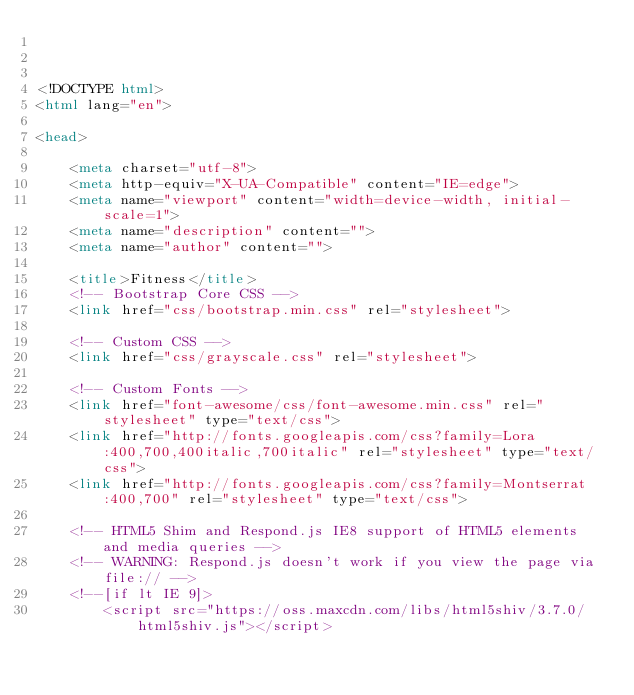<code> <loc_0><loc_0><loc_500><loc_500><_HTML_>


<!DOCTYPE html>
<html lang="en">

<head>

    <meta charset="utf-8">
    <meta http-equiv="X-UA-Compatible" content="IE=edge">
    <meta name="viewport" content="width=device-width, initial-scale=1">
    <meta name="description" content="">
    <meta name="author" content="">

    <title>Fitness</title>
    <!-- Bootstrap Core CSS -->
    <link href="css/bootstrap.min.css" rel="stylesheet">

    <!-- Custom CSS -->
    <link href="css/grayscale.css" rel="stylesheet">

    <!-- Custom Fonts -->
    <link href="font-awesome/css/font-awesome.min.css" rel="stylesheet" type="text/css">
    <link href="http://fonts.googleapis.com/css?family=Lora:400,700,400italic,700italic" rel="stylesheet" type="text/css">
    <link href="http://fonts.googleapis.com/css?family=Montserrat:400,700" rel="stylesheet" type="text/css">

    <!-- HTML5 Shim and Respond.js IE8 support of HTML5 elements and media queries -->
    <!-- WARNING: Respond.js doesn't work if you view the page via file:// -->
    <!--[if lt IE 9]>
        <script src="https://oss.maxcdn.com/libs/html5shiv/3.7.0/html5shiv.js"></script></code> 